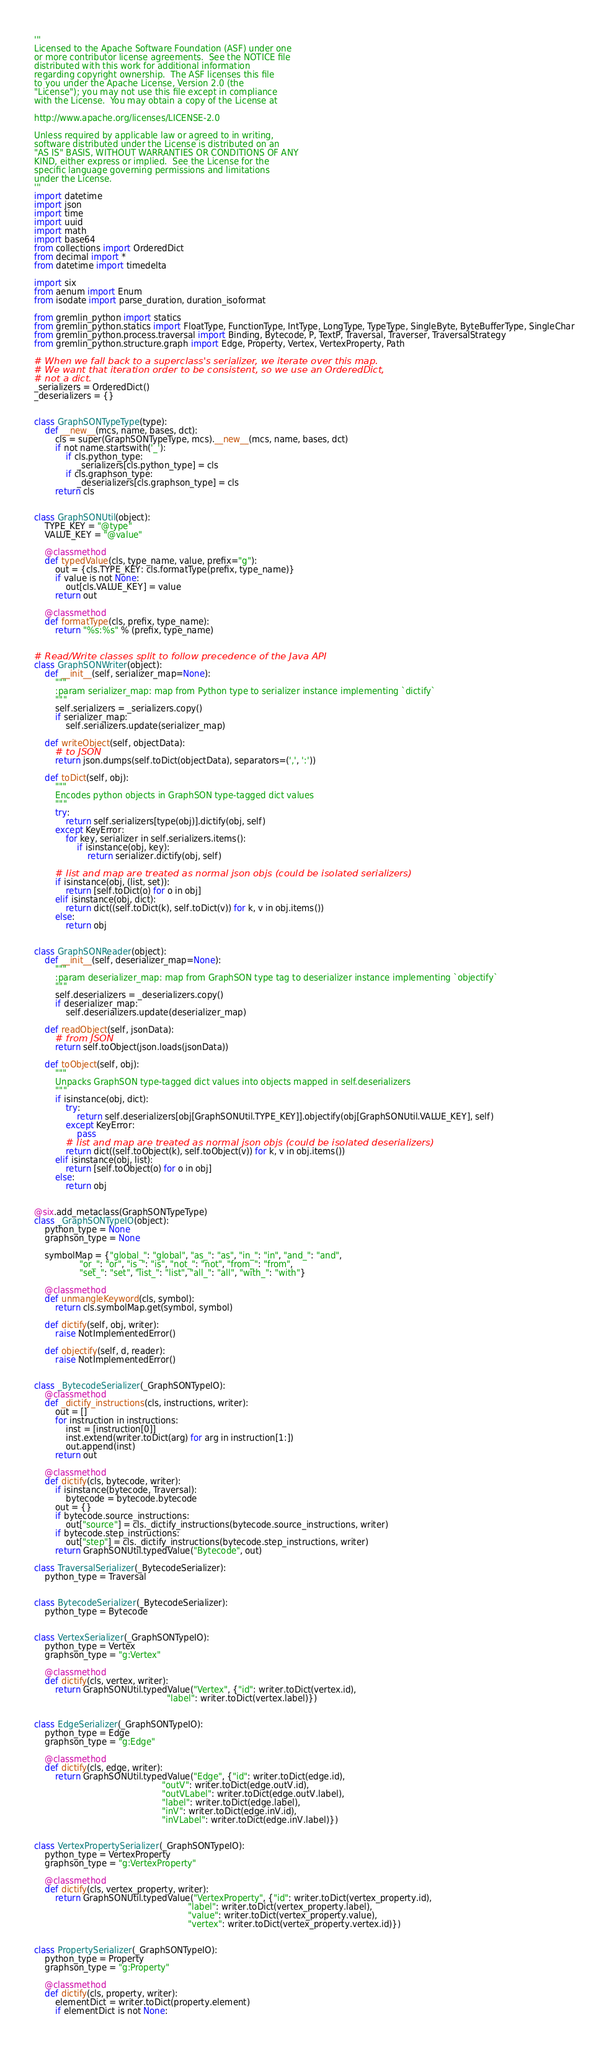Convert code to text. <code><loc_0><loc_0><loc_500><loc_500><_Python_>'''
Licensed to the Apache Software Foundation (ASF) under one
or more contributor license agreements.  See the NOTICE file
distributed with this work for additional information
regarding copyright ownership.  The ASF licenses this file
to you under the Apache License, Version 2.0 (the
"License"); you may not use this file except in compliance
with the License.  You may obtain a copy of the License at

http://www.apache.org/licenses/LICENSE-2.0

Unless required by applicable law or agreed to in writing,
software distributed under the License is distributed on an
"AS IS" BASIS, WITHOUT WARRANTIES OR CONDITIONS OF ANY
KIND, either express or implied.  See the License for the
specific language governing permissions and limitations
under the License.
'''
import datetime
import json
import time
import uuid
import math
import base64
from collections import OrderedDict
from decimal import *
from datetime import timedelta

import six
from aenum import Enum
from isodate import parse_duration, duration_isoformat

from gremlin_python import statics
from gremlin_python.statics import FloatType, FunctionType, IntType, LongType, TypeType, SingleByte, ByteBufferType, SingleChar
from gremlin_python.process.traversal import Binding, Bytecode, P, TextP, Traversal, Traverser, TraversalStrategy
from gremlin_python.structure.graph import Edge, Property, Vertex, VertexProperty, Path

# When we fall back to a superclass's serializer, we iterate over this map.
# We want that iteration order to be consistent, so we use an OrderedDict,
# not a dict.
_serializers = OrderedDict()
_deserializers = {}


class GraphSONTypeType(type):
    def __new__(mcs, name, bases, dct):
        cls = super(GraphSONTypeType, mcs).__new__(mcs, name, bases, dct)
        if not name.startswith('_'):
            if cls.python_type:
                _serializers[cls.python_type] = cls
            if cls.graphson_type:
                _deserializers[cls.graphson_type] = cls
        return cls


class GraphSONUtil(object):
    TYPE_KEY = "@type"
    VALUE_KEY = "@value"

    @classmethod
    def typedValue(cls, type_name, value, prefix="g"):
        out = {cls.TYPE_KEY: cls.formatType(prefix, type_name)}
        if value is not None:
            out[cls.VALUE_KEY] = value
        return out

    @classmethod
    def formatType(cls, prefix, type_name):
        return "%s:%s" % (prefix, type_name)


# Read/Write classes split to follow precedence of the Java API
class GraphSONWriter(object):
    def __init__(self, serializer_map=None):
        """
        :param serializer_map: map from Python type to serializer instance implementing `dictify`
        """
        self.serializers = _serializers.copy()
        if serializer_map:
            self.serializers.update(serializer_map)

    def writeObject(self, objectData):
        # to JSON
        return json.dumps(self.toDict(objectData), separators=(',', ':'))

    def toDict(self, obj):
        """
        Encodes python objects in GraphSON type-tagged dict values
        """
        try:
            return self.serializers[type(obj)].dictify(obj, self)
        except KeyError:
            for key, serializer in self.serializers.items():
                if isinstance(obj, key):
                    return serializer.dictify(obj, self)

        # list and map are treated as normal json objs (could be isolated serializers)
        if isinstance(obj, (list, set)):
            return [self.toDict(o) for o in obj]
        elif isinstance(obj, dict):
            return dict((self.toDict(k), self.toDict(v)) for k, v in obj.items())
        else:
            return obj


class GraphSONReader(object):
    def __init__(self, deserializer_map=None):
        """
        :param deserializer_map: map from GraphSON type tag to deserializer instance implementing `objectify`
        """
        self.deserializers = _deserializers.copy()
        if deserializer_map:
            self.deserializers.update(deserializer_map)

    def readObject(self, jsonData):
        # from JSON
        return self.toObject(json.loads(jsonData))

    def toObject(self, obj):
        """
        Unpacks GraphSON type-tagged dict values into objects mapped in self.deserializers
        """
        if isinstance(obj, dict):
            try:
                return self.deserializers[obj[GraphSONUtil.TYPE_KEY]].objectify(obj[GraphSONUtil.VALUE_KEY], self)
            except KeyError:
                pass
            # list and map are treated as normal json objs (could be isolated deserializers)
            return dict((self.toObject(k), self.toObject(v)) for k, v in obj.items())
        elif isinstance(obj, list):
            return [self.toObject(o) for o in obj]
        else:
            return obj


@six.add_metaclass(GraphSONTypeType)
class _GraphSONTypeIO(object):
    python_type = None
    graphson_type = None

    symbolMap = {"global_": "global", "as_": "as", "in_": "in", "and_": "and",
                 "or_": "or", "is_": "is", "not_": "not", "from_": "from",
                 "set_": "set", "list_": "list", "all_": "all", "with_": "with"}

    @classmethod
    def unmangleKeyword(cls, symbol):
        return cls.symbolMap.get(symbol, symbol)

    def dictify(self, obj, writer):
        raise NotImplementedError()

    def objectify(self, d, reader):
        raise NotImplementedError()


class _BytecodeSerializer(_GraphSONTypeIO):
    @classmethod
    def _dictify_instructions(cls, instructions, writer):
        out = []
        for instruction in instructions:
            inst = [instruction[0]]
            inst.extend(writer.toDict(arg) for arg in instruction[1:])
            out.append(inst)
        return out

    @classmethod
    def dictify(cls, bytecode, writer):
        if isinstance(bytecode, Traversal):
            bytecode = bytecode.bytecode
        out = {}
        if bytecode.source_instructions:
            out["source"] = cls._dictify_instructions(bytecode.source_instructions, writer)
        if bytecode.step_instructions:
            out["step"] = cls._dictify_instructions(bytecode.step_instructions, writer)
        return GraphSONUtil.typedValue("Bytecode", out)

class TraversalSerializer(_BytecodeSerializer):
    python_type = Traversal


class BytecodeSerializer(_BytecodeSerializer):
    python_type = Bytecode


class VertexSerializer(_GraphSONTypeIO):
    python_type = Vertex
    graphson_type = "g:Vertex"

    @classmethod
    def dictify(cls, vertex, writer):
        return GraphSONUtil.typedValue("Vertex", {"id": writer.toDict(vertex.id),
                                                  "label": writer.toDict(vertex.label)})


class EdgeSerializer(_GraphSONTypeIO):
    python_type = Edge
    graphson_type = "g:Edge"

    @classmethod
    def dictify(cls, edge, writer):
        return GraphSONUtil.typedValue("Edge", {"id": writer.toDict(edge.id),
                                                "outV": writer.toDict(edge.outV.id),
                                                "outVLabel": writer.toDict(edge.outV.label),
                                                "label": writer.toDict(edge.label),
                                                "inV": writer.toDict(edge.inV.id),
                                                "inVLabel": writer.toDict(edge.inV.label)})


class VertexPropertySerializer(_GraphSONTypeIO):
    python_type = VertexProperty
    graphson_type = "g:VertexProperty"

    @classmethod
    def dictify(cls, vertex_property, writer):
        return GraphSONUtil.typedValue("VertexProperty", {"id": writer.toDict(vertex_property.id),
                                                          "label": writer.toDict(vertex_property.label),
                                                          "value": writer.toDict(vertex_property.value),
                                                          "vertex": writer.toDict(vertex_property.vertex.id)})


class PropertySerializer(_GraphSONTypeIO):
    python_type = Property
    graphson_type = "g:Property"

    @classmethod
    def dictify(cls, property, writer):
        elementDict = writer.toDict(property.element)
        if elementDict is not None:</code> 